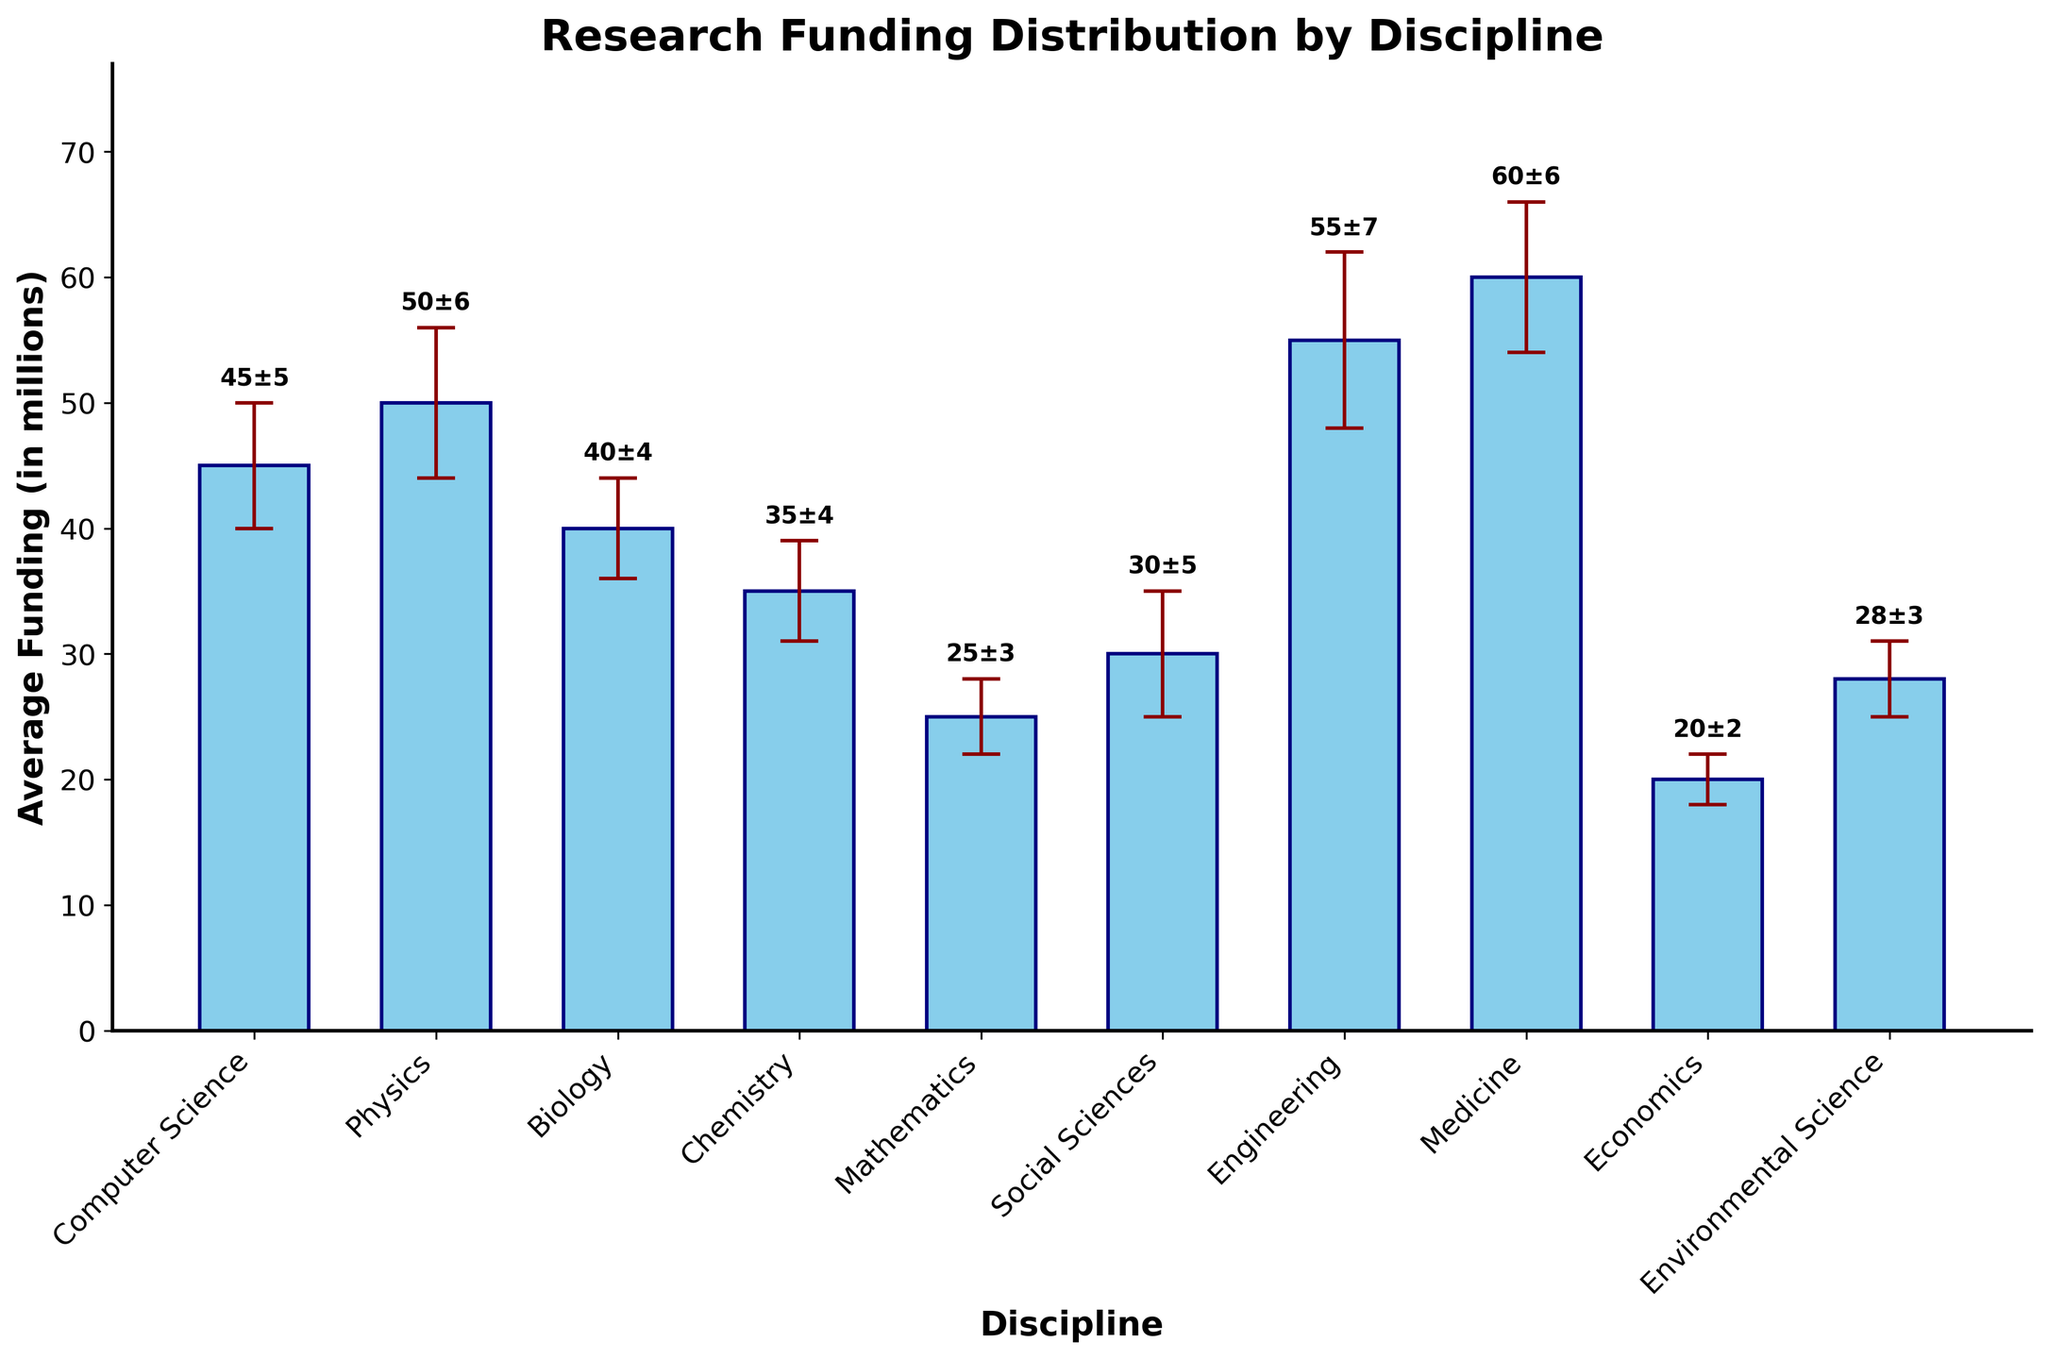What is the title of the figure? The title is shown at the top of the figure. It is written as 'Research Funding Distribution by Discipline'.
Answer: Research Funding Distribution by Discipline Which discipline received the highest average funding? The bar for Medicine is the tallest in the figure, showing the highest average funding.
Answer: Medicine What is the average funding for Computer Science with its uncertainty? The label on top of the bar for Computer Science reads '45±5', indicating that the average funding is 45 million with an uncertainty of 5 million.
Answer: 45±5 How many disciplines have their average funding between 20 to 40 million? The bars for Biology (40), Chemistry (35), Mathematics (25), Social Sciences (30), Economics (20), and Environmental Science (28) fall within the range of 20 to 40 million, making a total of 6 disciplines.
Answer: 6 What is the difference in average funding between Engineering and Mathematics? The average funding for Engineering is 55 million and for Mathematics is 25 million. The difference is calculated as 55 - 25.
Answer: 30 million Which disciplines have the same uncertainty? Both Chemistry and Biology have an uncertainty of 4 million, as shown by the lengths of their error bars.
Answer: Chemistry and Biology What is the sum of the uncertainties for Social Sciences and Economics? The uncertainty for Social Sciences is 5 million, and for Economics, it is 2 million. Their sum is 5 + 2.
Answer: 7 million Which discipline has the smallest average funding? The shortest bar corresponds to Economics, which has the smallest average funding at 20 million.
Answer: Economics Is the uncertainty for Physics greater than that for Mathematics? The uncertainty for Physics is shown as 6 million, and for Mathematics, it is 3 million. Therefore, 6 is greater than 3.
Answer: Yes By how much does the average funding for Medicine exceed that for Computer Science? The average funding for Medicine is 60 million, and for Computer Science, it is 45 million. The difference is 60 - 45.
Answer: 15 million 